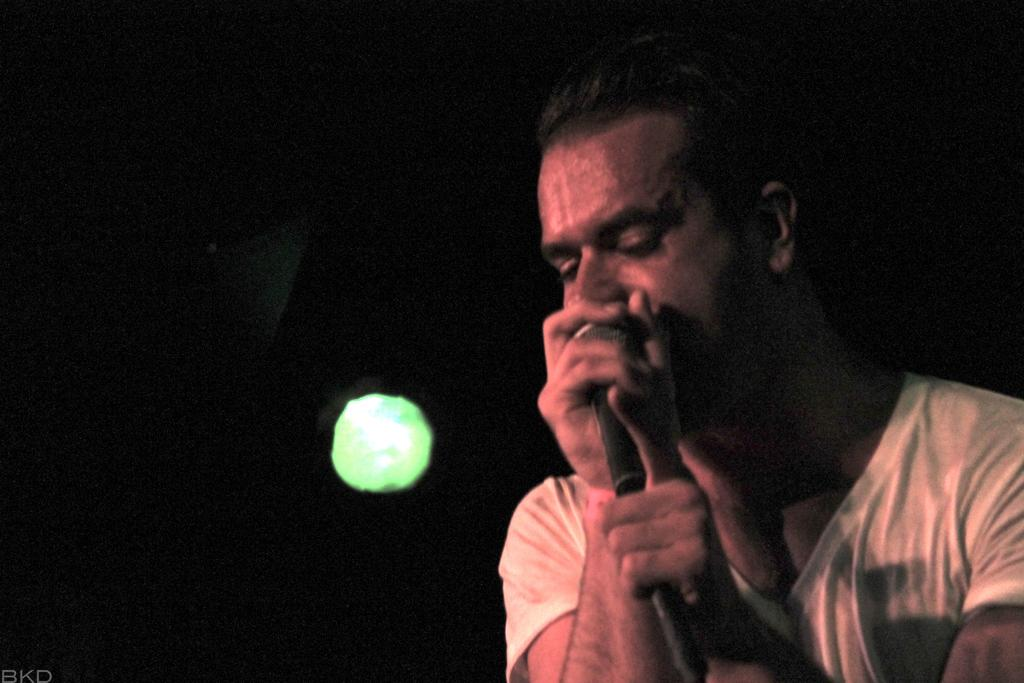What is the person on the right side of the image holding? The person is holding a mic. How would you describe the lighting in the image? The background is dark. Can you identify any specific colors in the background? Yes, there is a green light in the background. Is there any text or logo visible in the image? Yes, there is a watermark in the left corner of the image. What type of fan is visible in the image? There is no fan present in the image. Can you describe the night sky in the image? The image does not depict a night sky; it has a dark background with a green light. 